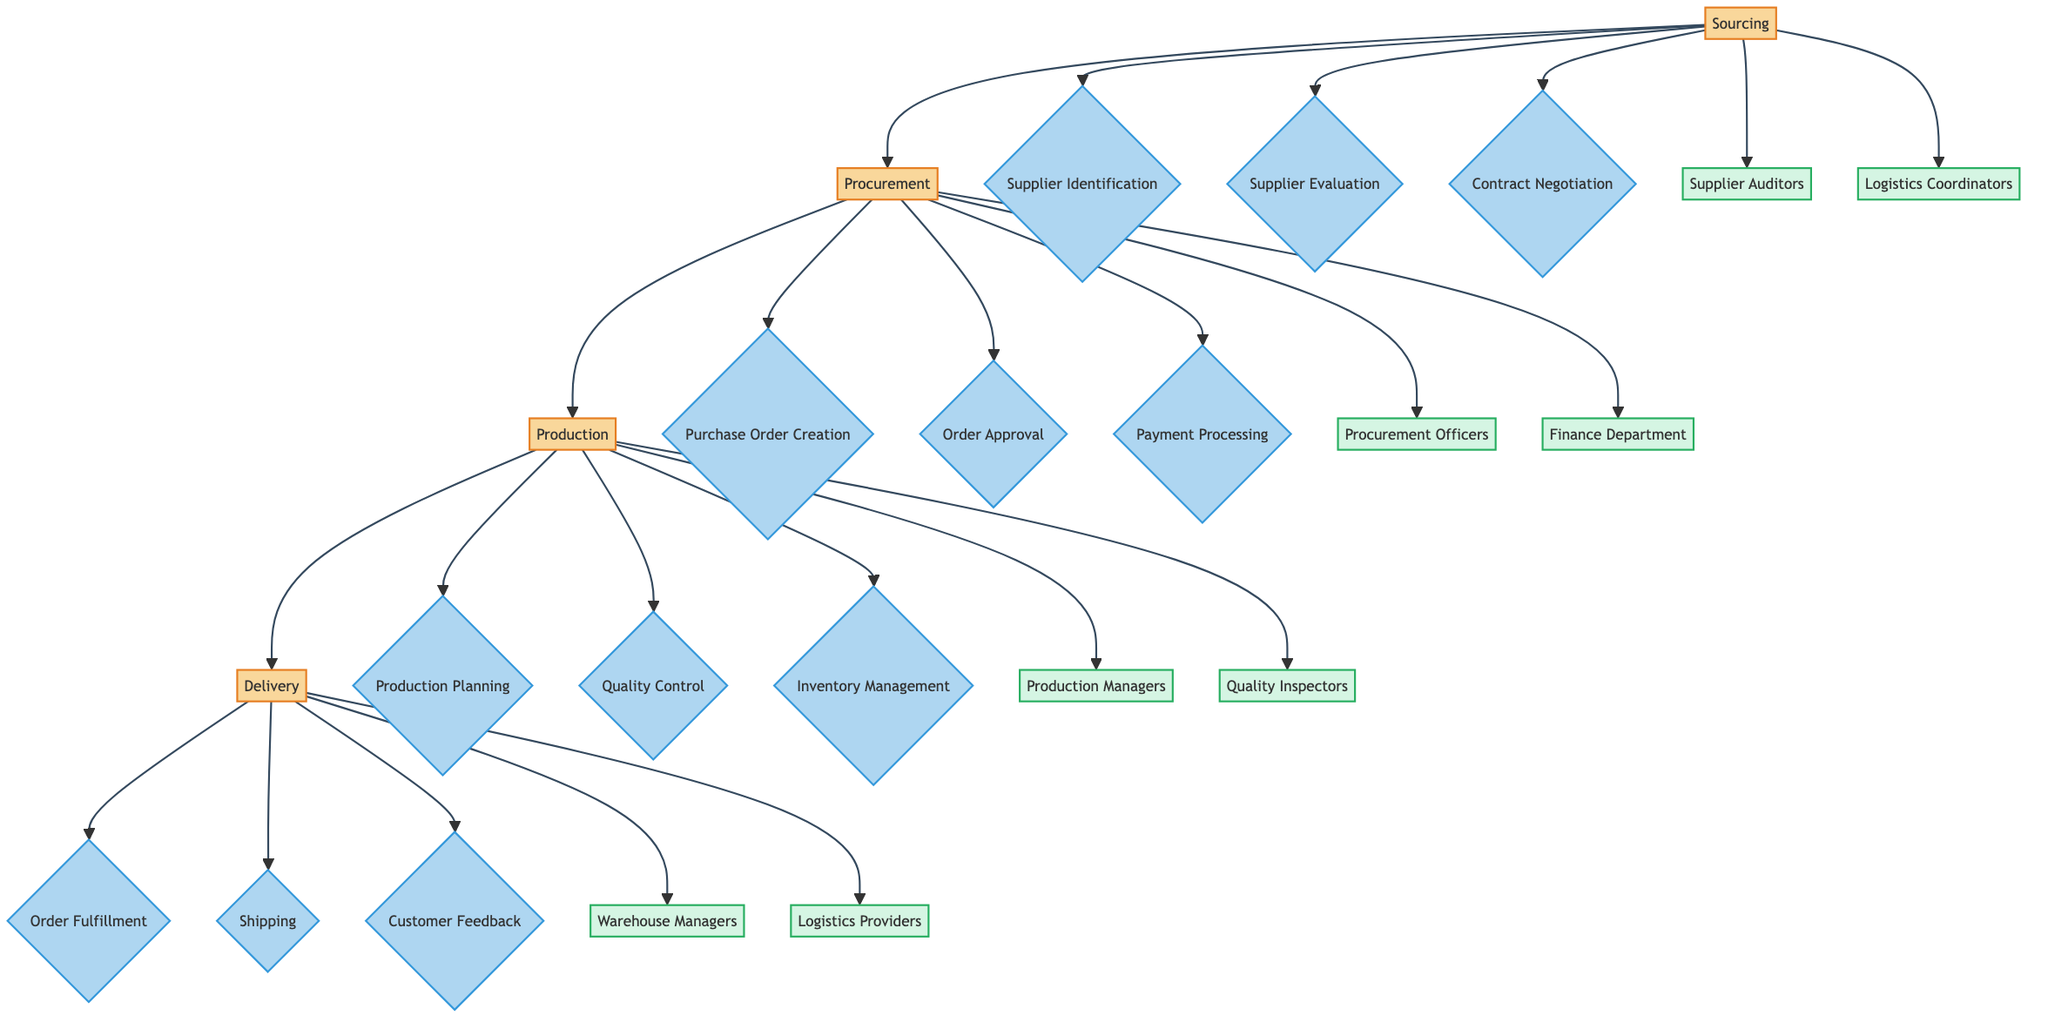What is the first step in the supply chain management process? The diagram indicates that the first step is "Sourcing," as it is the starting point from which the processes flow toward procurement, production, and delivery.
Answer: Sourcing How many key decision points are there in the Procurement phase? The Procurement phase lists three key decision points: Purchase Order Creation, Order Approval, and Payment Processing, which are shown under the Procurement node.
Answer: 3 What intermediary is involved in the Delivery phase? According to the diagram, the intermediaries involved in the Delivery phase include Warehouse Managers and Logistics Providers, which are listed under the Delivery node.
Answer: Warehouse Managers, Logistics Providers Which phase follows Production? The diagram shows a direct flow from the Production phase to the Delivery phase, indicating that Delivery is the next step after Production.
Answer: Delivery What are the key decision points in the Sourcing step? The Sourcing step lists three key decision points: Supplier Identification, Supplier Evaluation, and Contract Negotiation, which detail the important decisions made during this phase.
Answer: Supplier Identification, Supplier Evaluation, Contract Negotiation Which intermediary is associated with the Procurement phase? The diagram indicates that Procurement Officers and the Finance Department are intermediaries associated with the Procurement phase, as shown below the procurement node.
Answer: Procurement Officers, Finance Department What is the last key decision point in the Production phase? The last key decision point listed in the Production phase is Inventory Management, which is positioned at the end of the decision points column under Production.
Answer: Inventory Management How many phases are shown in the diagram? The diagram shows four phases in total: Sourcing, Procurement, Production, and Delivery, which are connected sequentially from left to right.
Answer: 4 Which decision point in the Delivery phase focuses on customer interaction? The decision point "Customer Feedback" under the Delivery phase specifically focuses on obtaining insights from customers regarding their experience, making it customer interaction-centric.
Answer: Customer Feedback 